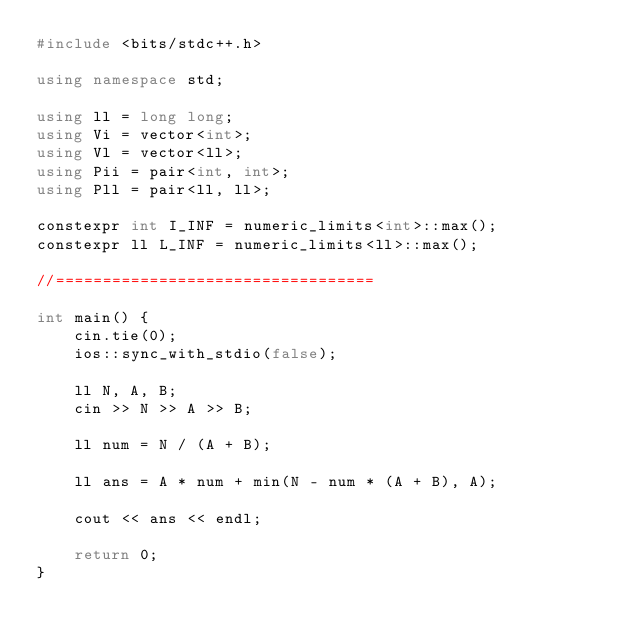Convert code to text. <code><loc_0><loc_0><loc_500><loc_500><_C++_>#include <bits/stdc++.h>

using namespace std;

using ll = long long;
using Vi = vector<int>;
using Vl = vector<ll>;
using Pii = pair<int, int>;
using Pll = pair<ll, ll>;

constexpr int I_INF = numeric_limits<int>::max();
constexpr ll L_INF = numeric_limits<ll>::max();

//==================================

int main() {
    cin.tie(0);
    ios::sync_with_stdio(false);

    ll N, A, B;
    cin >> N >> A >> B;

    ll num = N / (A + B);

    ll ans = A * num + min(N - num * (A + B), A);

    cout << ans << endl;

    return 0;
}</code> 